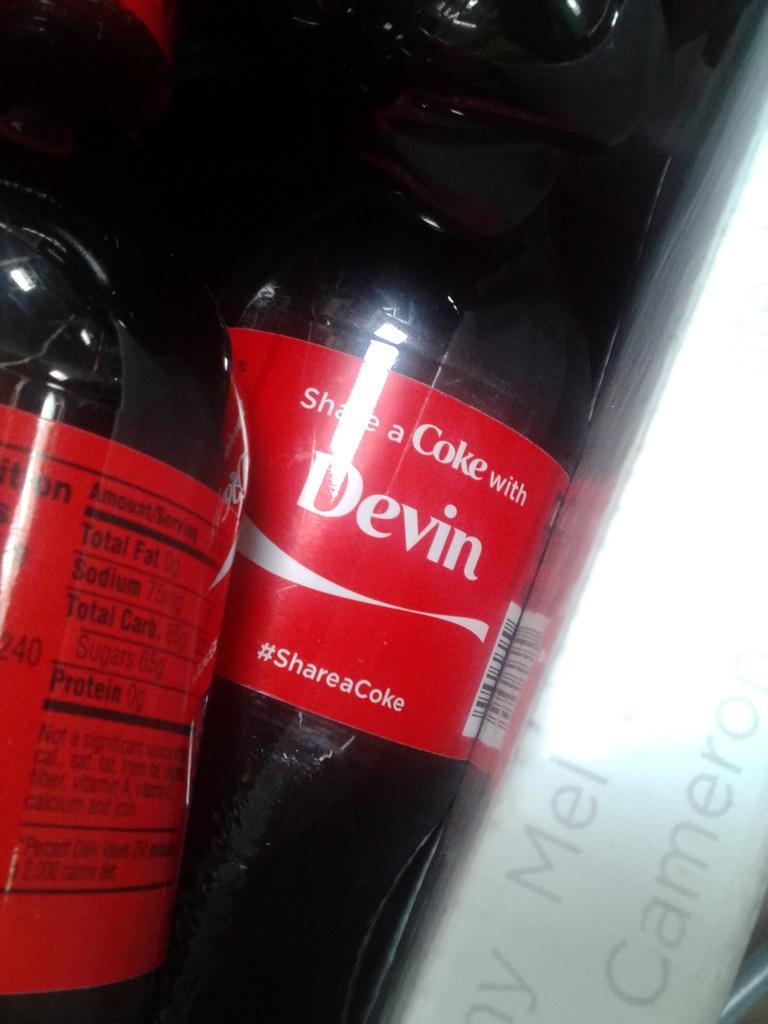Who should this coke be shared with?
Make the answer very short. Devin. What is the hashtag?
Your answer should be very brief. #shareacoke. 